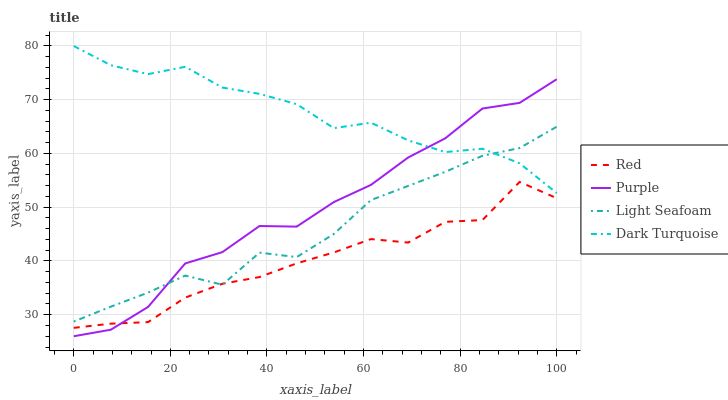Does Red have the minimum area under the curve?
Answer yes or no. Yes. Does Dark Turquoise have the maximum area under the curve?
Answer yes or no. Yes. Does Light Seafoam have the minimum area under the curve?
Answer yes or no. No. Does Light Seafoam have the maximum area under the curve?
Answer yes or no. No. Is Light Seafoam the smoothest?
Answer yes or no. Yes. Is Purple the roughest?
Answer yes or no. Yes. Is Dark Turquoise the smoothest?
Answer yes or no. No. Is Dark Turquoise the roughest?
Answer yes or no. No. Does Light Seafoam have the lowest value?
Answer yes or no. No. Does Light Seafoam have the highest value?
Answer yes or no. No. Is Red less than Dark Turquoise?
Answer yes or no. Yes. Is Dark Turquoise greater than Red?
Answer yes or no. Yes. Does Red intersect Dark Turquoise?
Answer yes or no. No. 